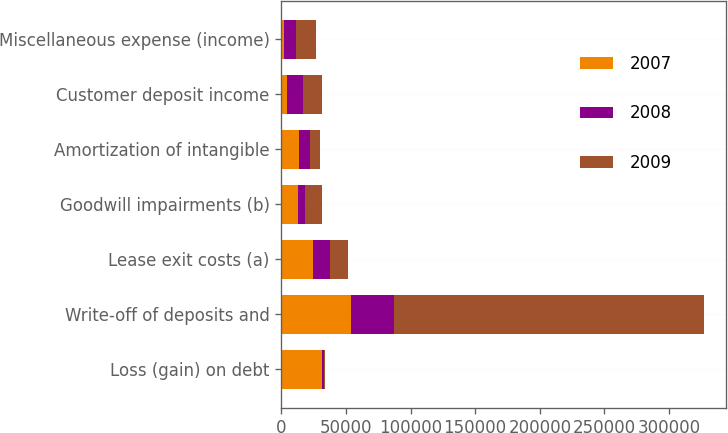Convert chart. <chart><loc_0><loc_0><loc_500><loc_500><stacked_bar_chart><ecel><fcel>Loss (gain) on debt<fcel>Write-off of deposits and<fcel>Lease exit costs (a)<fcel>Goodwill impairments (b)<fcel>Amortization of intangible<fcel>Customer deposit income<fcel>Miscellaneous expense (income)<nl><fcel>2007<fcel>31594<fcel>54256<fcel>24803<fcel>13260<fcel>14008<fcel>4213<fcel>2391<nl><fcel>2008<fcel>1594<fcel>33309<fcel>13260<fcel>4954<fcel>8151<fcel>12960<fcel>8737<nl><fcel>2009<fcel>543<fcel>239716<fcel>13681<fcel>13260<fcel>8150<fcel>14705<fcel>15625<nl></chart> 